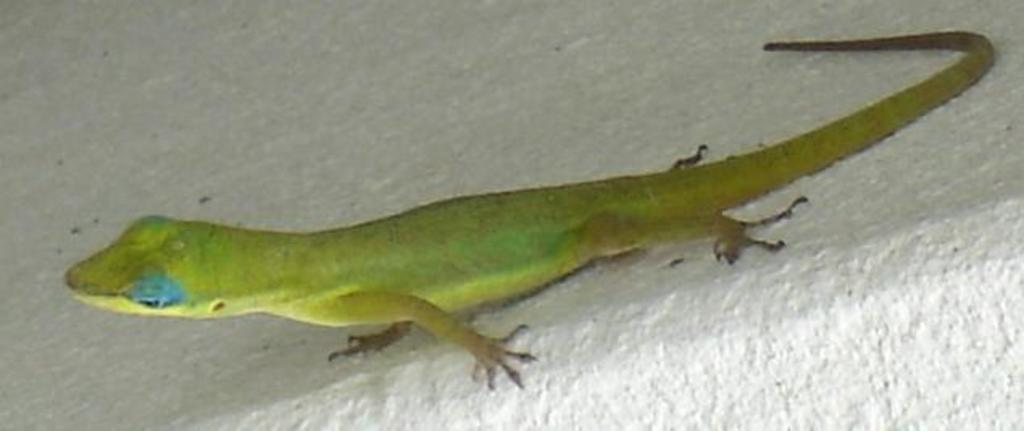What type of animal is in the image? There is a lizard in the image. Where is the lizard located? The lizard is on a surface. What type of comb is the lizard using in the image? There is no comb present in the image, as it features a lizard on a surface. 